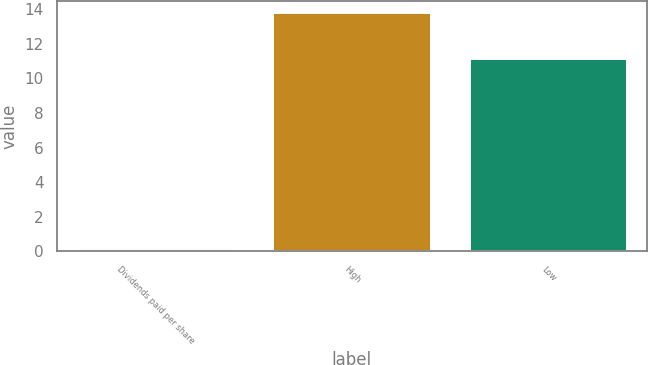<chart> <loc_0><loc_0><loc_500><loc_500><bar_chart><fcel>Dividends paid per share<fcel>High<fcel>Low<nl><fcel>0.15<fcel>13.79<fcel>11.15<nl></chart> 